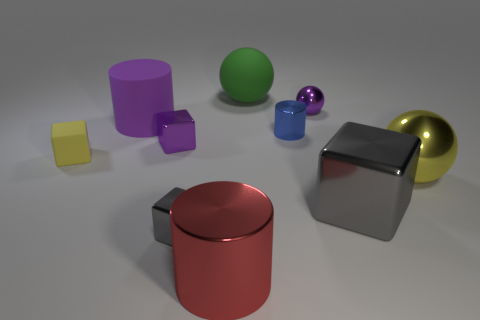Subtract all tiny purple cubes. How many cubes are left? 3 Subtract all purple cylinders. How many cylinders are left? 2 Subtract 1 cylinders. How many cylinders are left? 2 Subtract all spheres. How many objects are left? 7 Subtract all purple cubes. Subtract all blue spheres. How many cubes are left? 3 Subtract all red blocks. How many green cylinders are left? 0 Subtract all tiny gray things. Subtract all gray things. How many objects are left? 7 Add 1 green objects. How many green objects are left? 2 Add 6 big gray cubes. How many big gray cubes exist? 7 Subtract 0 brown cylinders. How many objects are left? 10 